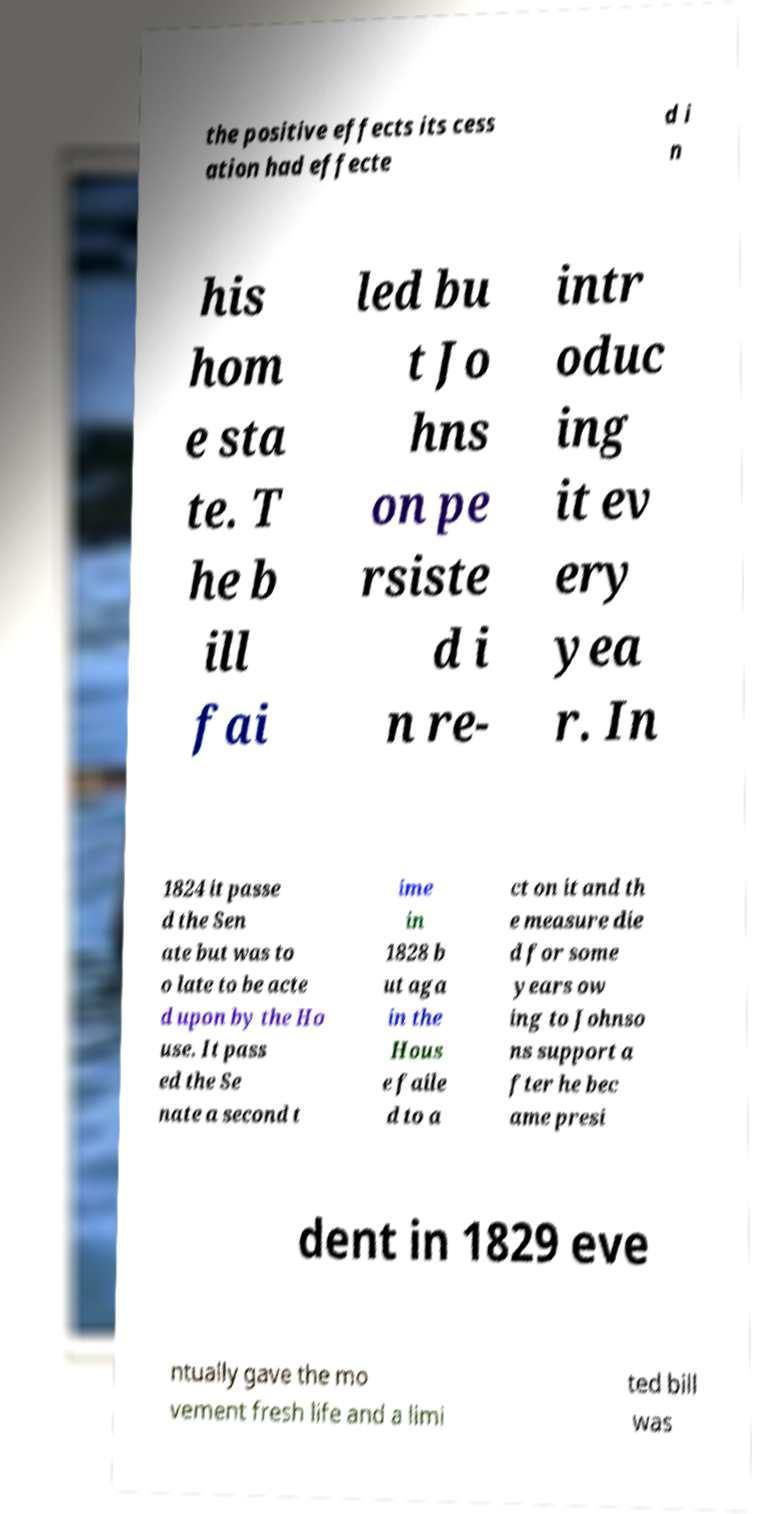What messages or text are displayed in this image? I need them in a readable, typed format. the positive effects its cess ation had effecte d i n his hom e sta te. T he b ill fai led bu t Jo hns on pe rsiste d i n re- intr oduc ing it ev ery yea r. In 1824 it passe d the Sen ate but was to o late to be acte d upon by the Ho use. It pass ed the Se nate a second t ime in 1828 b ut aga in the Hous e faile d to a ct on it and th e measure die d for some years ow ing to Johnso ns support a fter he bec ame presi dent in 1829 eve ntually gave the mo vement fresh life and a limi ted bill was 